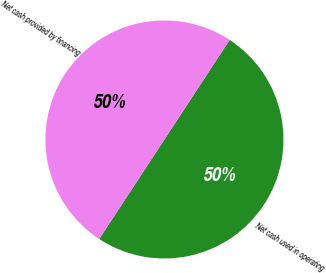Convert chart to OTSL. <chart><loc_0><loc_0><loc_500><loc_500><pie_chart><fcel>Net cash used in operating<fcel>Net cash provided by financing<nl><fcel>50.0%<fcel>50.0%<nl></chart> 